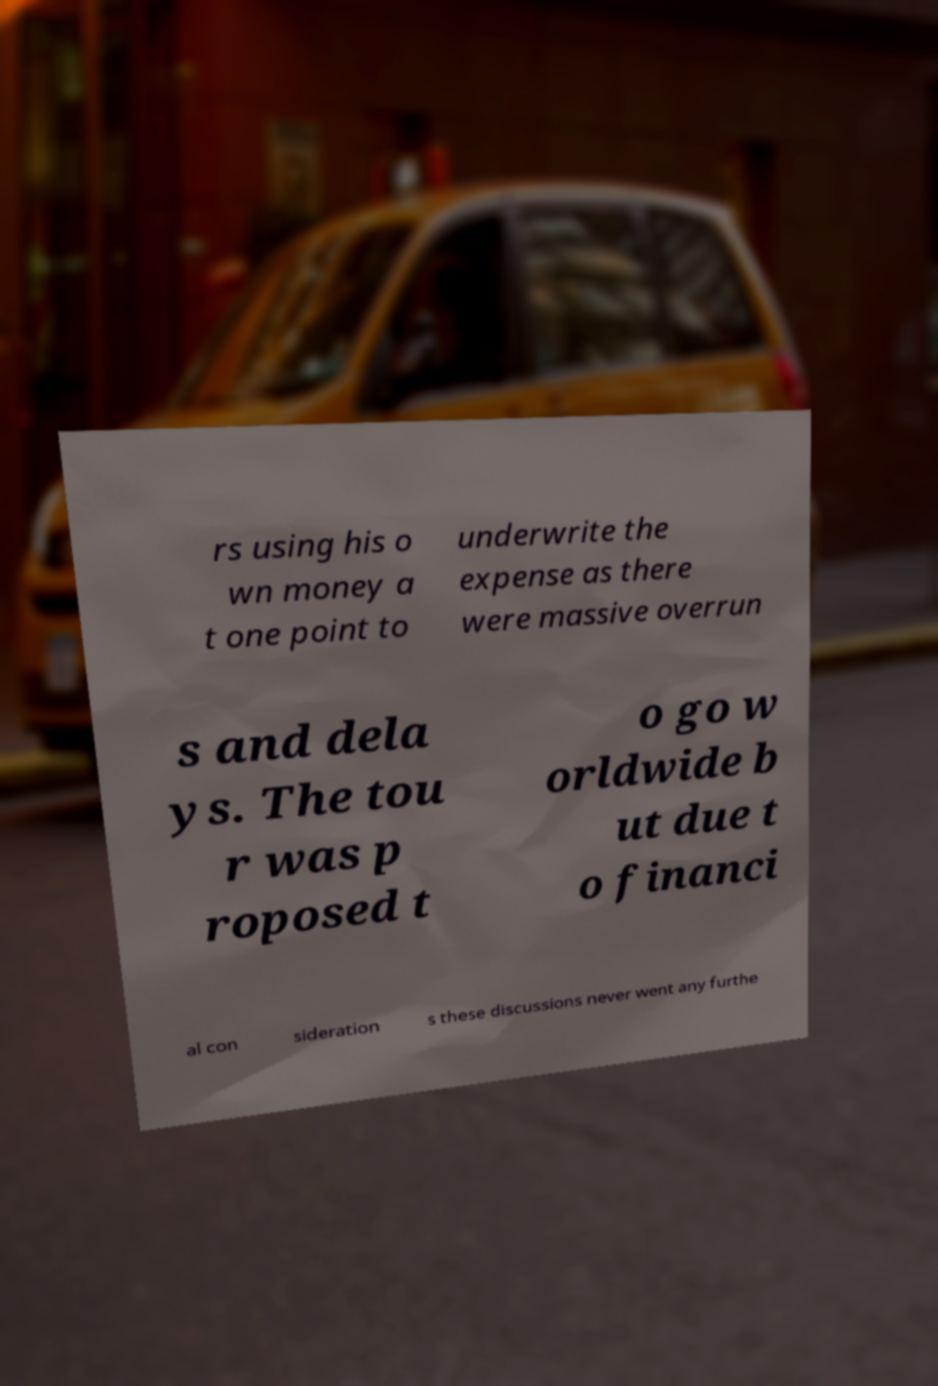I need the written content from this picture converted into text. Can you do that? rs using his o wn money a t one point to underwrite the expense as there were massive overrun s and dela ys. The tou r was p roposed t o go w orldwide b ut due t o financi al con sideration s these discussions never went any furthe 